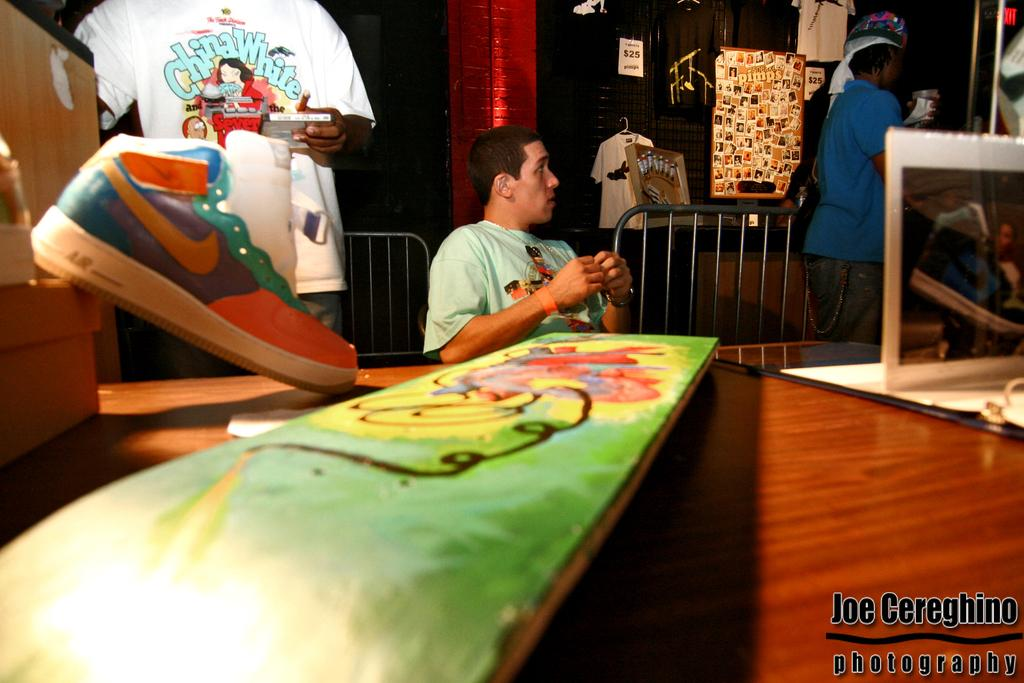Provide a one-sentence caption for the provided image. Art work with a tshirt that has China White in blue lettering. 